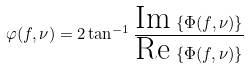<formula> <loc_0><loc_0><loc_500><loc_500>\varphi ( f , \nu ) = 2 \tan ^ { - 1 } \frac { \text {Im} \, \left \{ \Phi ( f , \nu ) \right \} } { \text {Re} \, \left \{ \Phi ( f , \nu ) \right \} }</formula> 